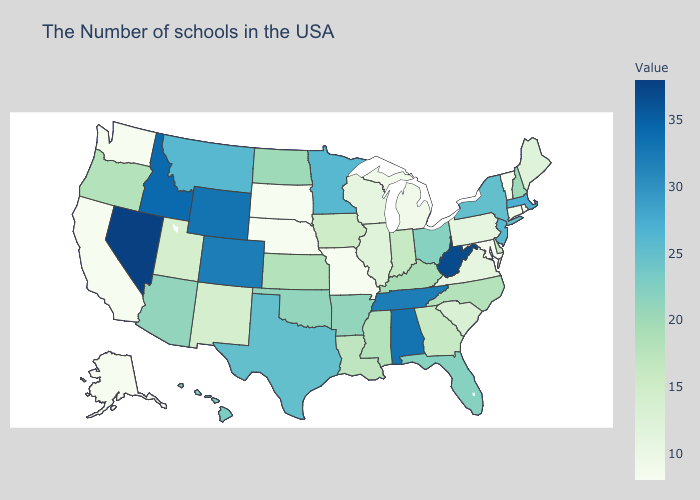Does the map have missing data?
Short answer required. No. Does Louisiana have the highest value in the South?
Write a very short answer. No. Does Nevada have the highest value in the USA?
Quick response, please. Yes. Does Arizona have a higher value than Alabama?
Quick response, please. No. Among the states that border Ohio , which have the lowest value?
Concise answer only. Michigan. Among the states that border West Virginia , which have the lowest value?
Quick response, please. Maryland. Which states have the lowest value in the USA?
Concise answer only. Rhode Island, Vermont, Maryland, Missouri, Nebraska, South Dakota, California, Washington, Alaska. 